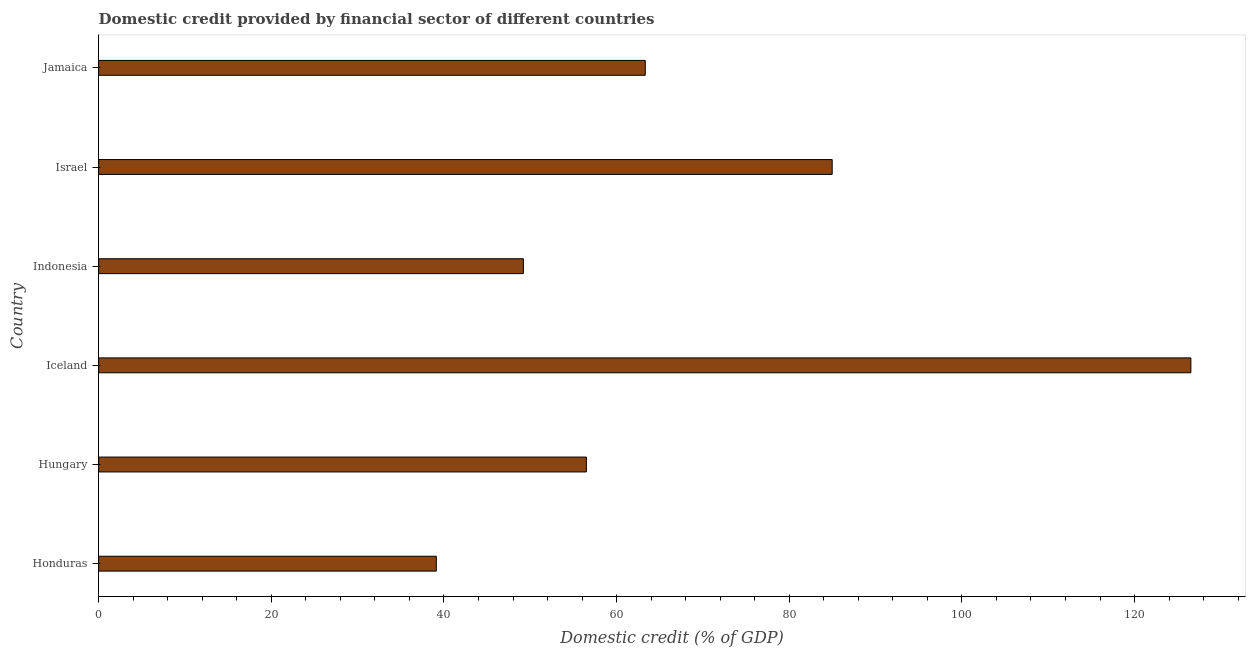What is the title of the graph?
Provide a succinct answer. Domestic credit provided by financial sector of different countries. What is the label or title of the X-axis?
Make the answer very short. Domestic credit (% of GDP). What is the domestic credit provided by financial sector in Indonesia?
Keep it short and to the point. 49.2. Across all countries, what is the maximum domestic credit provided by financial sector?
Your response must be concise. 126.52. Across all countries, what is the minimum domestic credit provided by financial sector?
Offer a very short reply. 39.12. In which country was the domestic credit provided by financial sector maximum?
Offer a very short reply. Iceland. In which country was the domestic credit provided by financial sector minimum?
Provide a short and direct response. Honduras. What is the sum of the domestic credit provided by financial sector?
Keep it short and to the point. 419.63. What is the difference between the domestic credit provided by financial sector in Iceland and Israel?
Ensure brevity in your answer.  41.55. What is the average domestic credit provided by financial sector per country?
Your answer should be compact. 69.94. What is the median domestic credit provided by financial sector?
Your response must be concise. 59.91. In how many countries, is the domestic credit provided by financial sector greater than 84 %?
Your answer should be very brief. 2. What is the ratio of the domestic credit provided by financial sector in Hungary to that in Indonesia?
Offer a very short reply. 1.15. Is the domestic credit provided by financial sector in Iceland less than that in Jamaica?
Offer a terse response. No. What is the difference between the highest and the second highest domestic credit provided by financial sector?
Provide a succinct answer. 41.55. What is the difference between the highest and the lowest domestic credit provided by financial sector?
Offer a terse response. 87.4. How many countries are there in the graph?
Your response must be concise. 6. What is the difference between two consecutive major ticks on the X-axis?
Your answer should be compact. 20. Are the values on the major ticks of X-axis written in scientific E-notation?
Keep it short and to the point. No. What is the Domestic credit (% of GDP) in Honduras?
Keep it short and to the point. 39.12. What is the Domestic credit (% of GDP) of Hungary?
Offer a terse response. 56.5. What is the Domestic credit (% of GDP) in Iceland?
Provide a short and direct response. 126.52. What is the Domestic credit (% of GDP) of Indonesia?
Keep it short and to the point. 49.2. What is the Domestic credit (% of GDP) of Israel?
Keep it short and to the point. 84.97. What is the Domestic credit (% of GDP) of Jamaica?
Ensure brevity in your answer.  63.32. What is the difference between the Domestic credit (% of GDP) in Honduras and Hungary?
Your response must be concise. -17.38. What is the difference between the Domestic credit (% of GDP) in Honduras and Iceland?
Give a very brief answer. -87.4. What is the difference between the Domestic credit (% of GDP) in Honduras and Indonesia?
Make the answer very short. -10.09. What is the difference between the Domestic credit (% of GDP) in Honduras and Israel?
Give a very brief answer. -45.85. What is the difference between the Domestic credit (% of GDP) in Honduras and Jamaica?
Make the answer very short. -24.2. What is the difference between the Domestic credit (% of GDP) in Hungary and Iceland?
Your answer should be very brief. -70.02. What is the difference between the Domestic credit (% of GDP) in Hungary and Indonesia?
Make the answer very short. 7.29. What is the difference between the Domestic credit (% of GDP) in Hungary and Israel?
Your response must be concise. -28.47. What is the difference between the Domestic credit (% of GDP) in Hungary and Jamaica?
Provide a succinct answer. -6.82. What is the difference between the Domestic credit (% of GDP) in Iceland and Indonesia?
Offer a very short reply. 77.32. What is the difference between the Domestic credit (% of GDP) in Iceland and Israel?
Offer a terse response. 41.55. What is the difference between the Domestic credit (% of GDP) in Iceland and Jamaica?
Provide a short and direct response. 63.2. What is the difference between the Domestic credit (% of GDP) in Indonesia and Israel?
Keep it short and to the point. -35.77. What is the difference between the Domestic credit (% of GDP) in Indonesia and Jamaica?
Offer a terse response. -14.12. What is the difference between the Domestic credit (% of GDP) in Israel and Jamaica?
Keep it short and to the point. 21.65. What is the ratio of the Domestic credit (% of GDP) in Honduras to that in Hungary?
Give a very brief answer. 0.69. What is the ratio of the Domestic credit (% of GDP) in Honduras to that in Iceland?
Offer a very short reply. 0.31. What is the ratio of the Domestic credit (% of GDP) in Honduras to that in Indonesia?
Your answer should be compact. 0.8. What is the ratio of the Domestic credit (% of GDP) in Honduras to that in Israel?
Offer a terse response. 0.46. What is the ratio of the Domestic credit (% of GDP) in Honduras to that in Jamaica?
Keep it short and to the point. 0.62. What is the ratio of the Domestic credit (% of GDP) in Hungary to that in Iceland?
Ensure brevity in your answer.  0.45. What is the ratio of the Domestic credit (% of GDP) in Hungary to that in Indonesia?
Give a very brief answer. 1.15. What is the ratio of the Domestic credit (% of GDP) in Hungary to that in Israel?
Provide a short and direct response. 0.67. What is the ratio of the Domestic credit (% of GDP) in Hungary to that in Jamaica?
Ensure brevity in your answer.  0.89. What is the ratio of the Domestic credit (% of GDP) in Iceland to that in Indonesia?
Keep it short and to the point. 2.57. What is the ratio of the Domestic credit (% of GDP) in Iceland to that in Israel?
Offer a terse response. 1.49. What is the ratio of the Domestic credit (% of GDP) in Iceland to that in Jamaica?
Offer a terse response. 2. What is the ratio of the Domestic credit (% of GDP) in Indonesia to that in Israel?
Offer a very short reply. 0.58. What is the ratio of the Domestic credit (% of GDP) in Indonesia to that in Jamaica?
Your answer should be very brief. 0.78. What is the ratio of the Domestic credit (% of GDP) in Israel to that in Jamaica?
Provide a short and direct response. 1.34. 